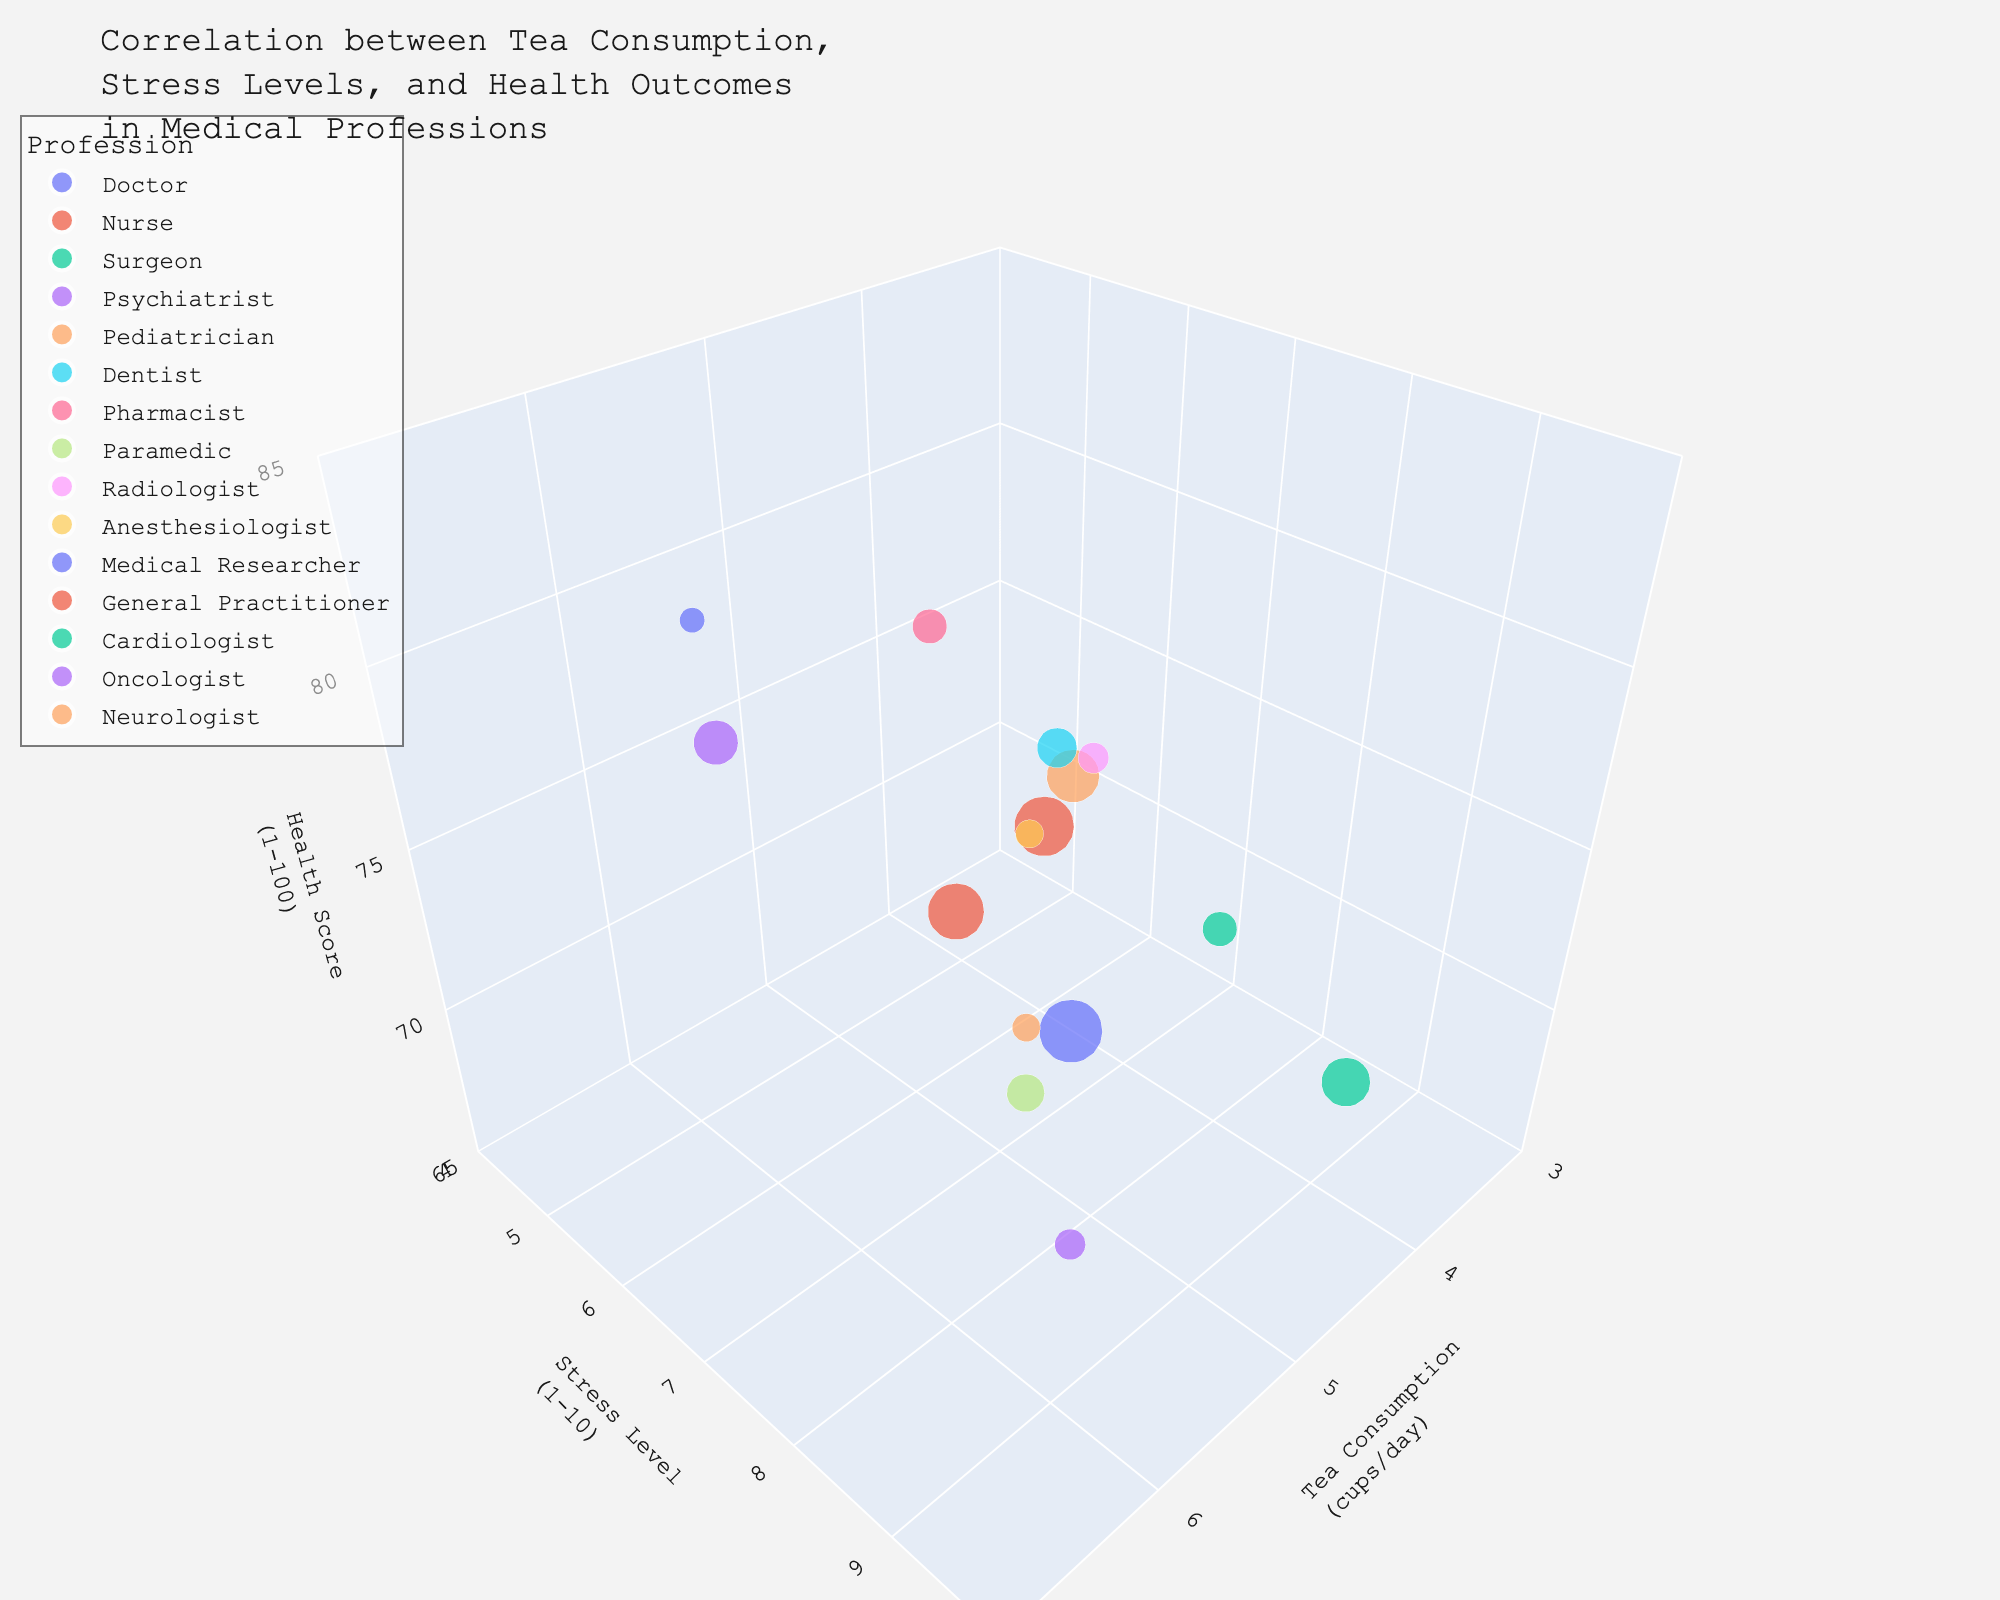what is the title of the figure? The title of the figure is usually placed at the top of the chart. By visually identifying the text at the top of the figure, the title can be read directly.
Answer: Correlation between Tea Consumption, Stress Levels, and Health Outcomes in Medical Professions Which profession has the highest tea consumption? To determine this, look for the profession with the largest x-coordinate value since tea consumption is represented on the x-axis.
Answer: Psychiatrist Which profession has the lowest health score? Identify the lowest z-coordinate value on the z-axis, which represents the health score, and note the corresponding profession.
Answer: Surgeon How many professions are displayed in the chart? Count the number of distinct data points in the figure, each representing a profession.
Answer: 15 Compare the stress levels between Doctors and Surgeons. Which has a higher stress level? Locate the data points for Doctors and Surgeons on the y-axis. The point with the higher y-coordinate (stress level) indicates the profession with higher stress levels.
Answer: Surgeon What is the sample size for Oncologists? Hover over the data point related to Oncologists. The sizing of the bubbles correlates with sample sizes, and the hover information will display the exact sample size.
Answer: 120 What is the average health score of Pediatricians and Radiologists? Identify the z-coordinate (Health Score) of the data points for Pediatricians and Radiologists. Calculate the average of these values. (76 + 73) / 2 = 74.5
Answer: 74.5 Which profession shows the highest level of stress but has a tea consumption less than 4 cups/day? Filter the data points where the x-coordinate (Tea Consumption) is less than 4. Among these, identify the point with the highest y-coordinate (Stress Level).
Answer: Surgeon Are there any professions with identical stress levels but different tea consumption? If so, which professions? Examine the y-coordinates of all data points and identify any pairs with the same y-coordinate but differing x-coordinates (Tea Consumption).
Answer: Doctor, Paramedic and Cardiologist, Neurologist What is the general trend between stress levels and health scores observed in the chart? Analyze the overall relationship by observing the distribution of data points along the y-axis (Stress Level) and their corresponding z-coordinates (Health Score). Identify any patterns or trends, whether positive or negative.
Answer: Higher stress levels generally correlate with lower health scores 